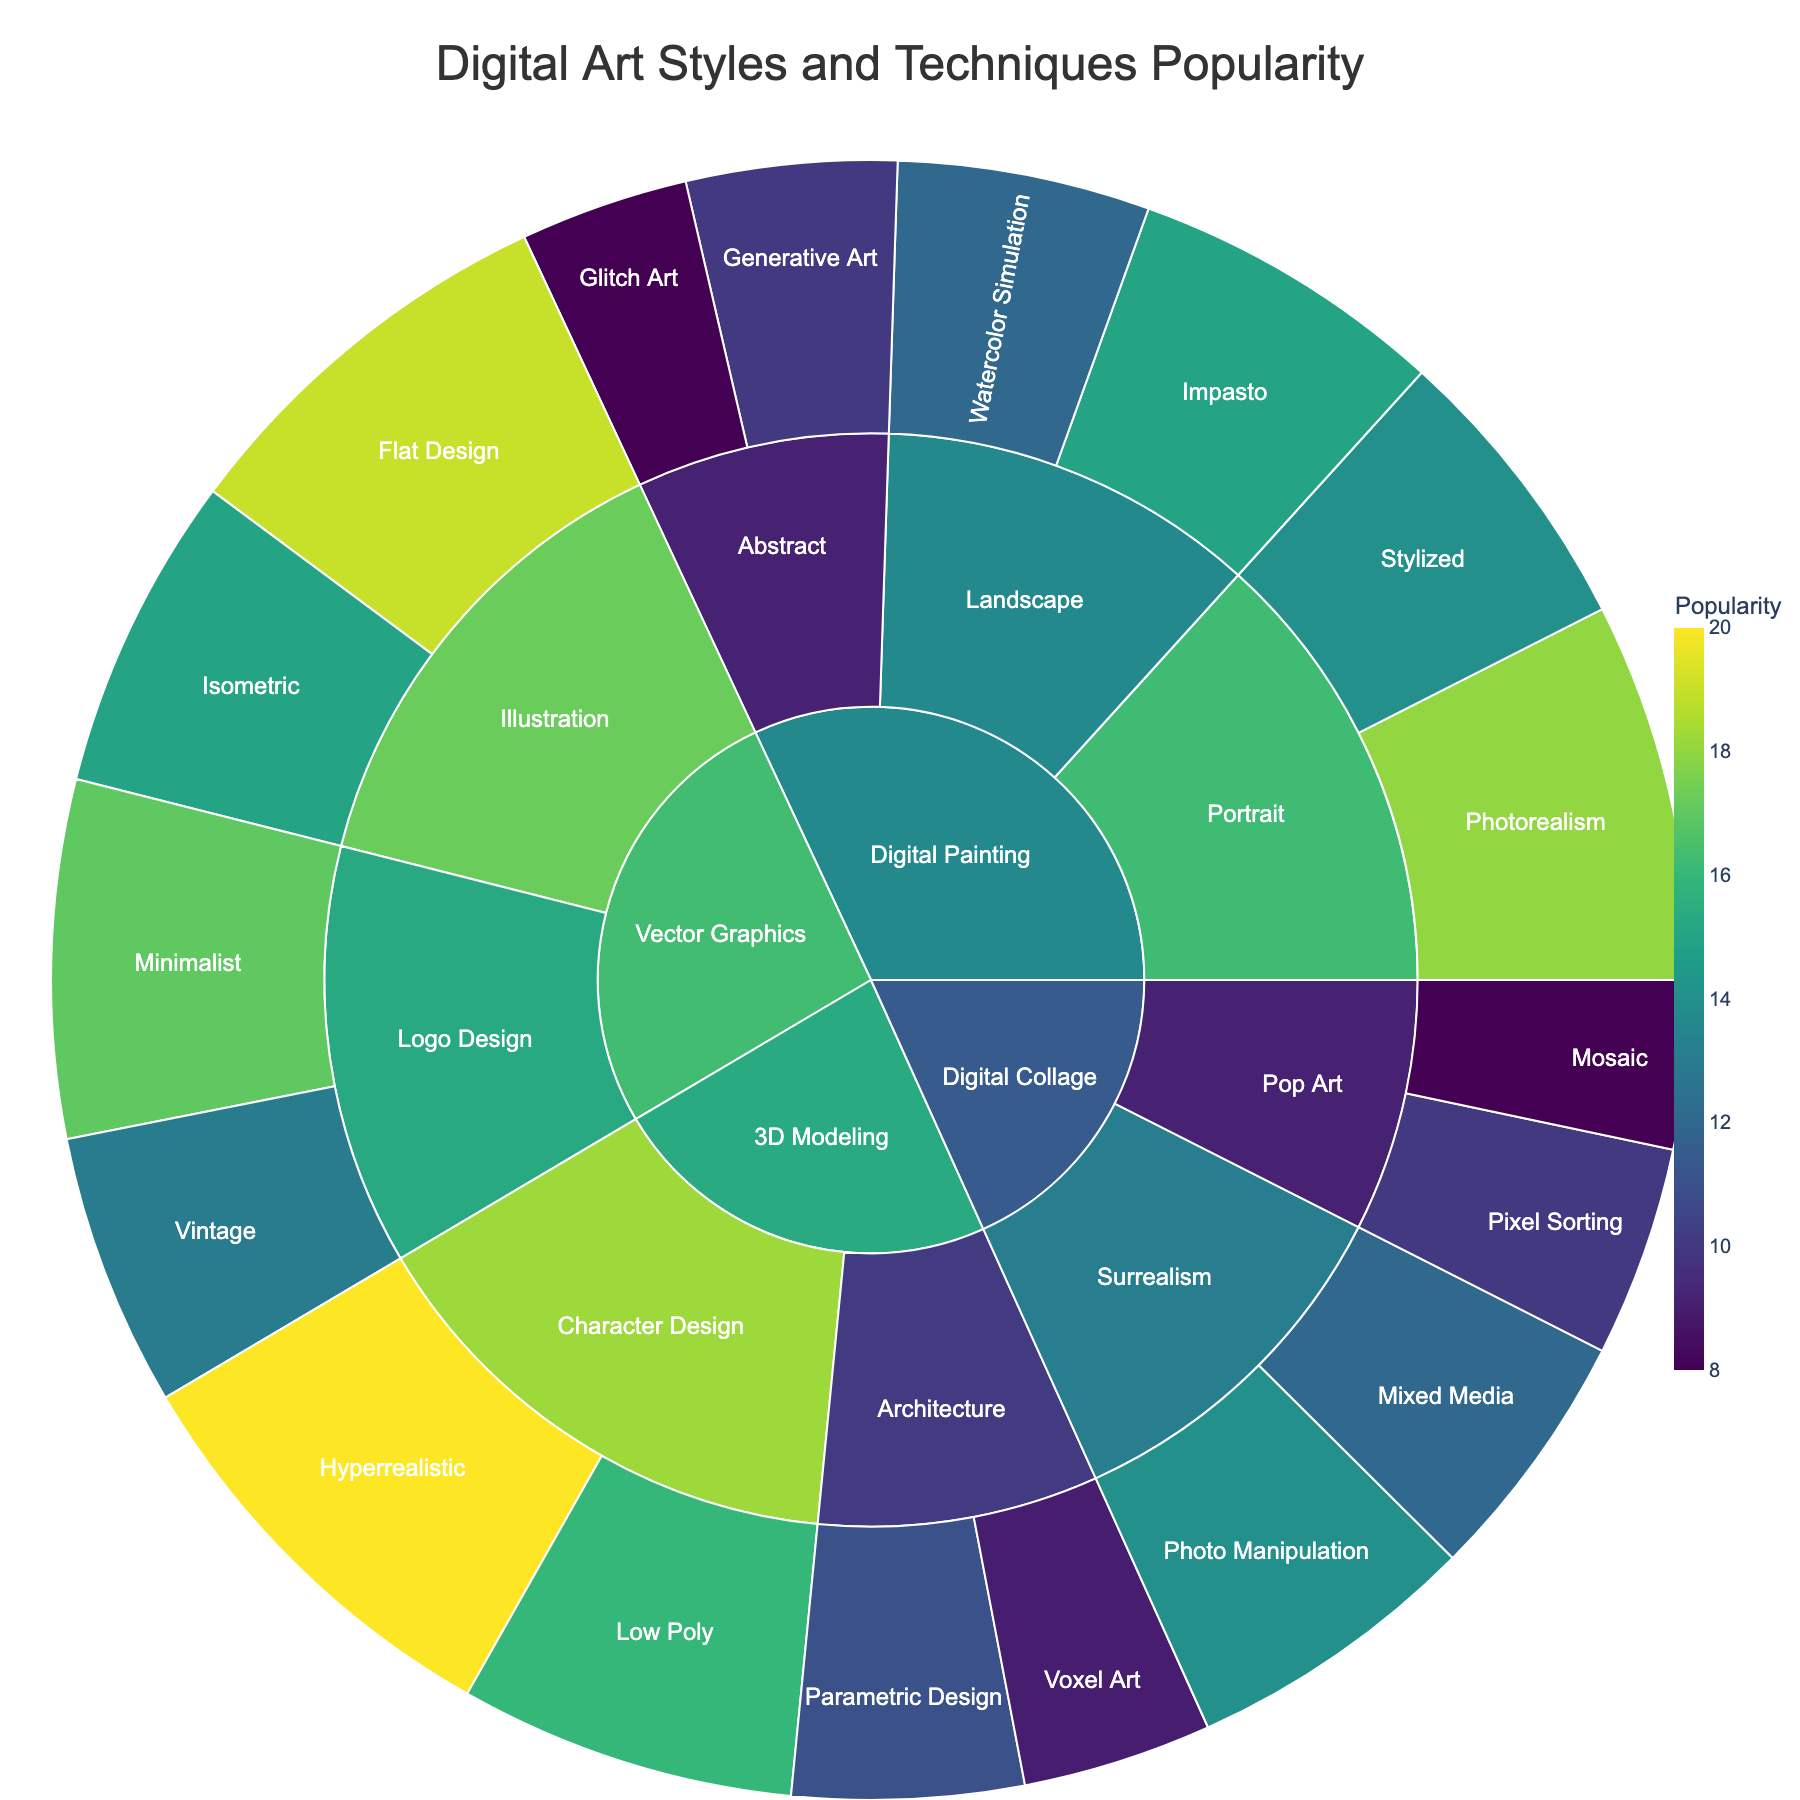What is the most popular digital art technique for the "Digital Painting" category? Look at the "Digital Painting" category and review the popularity values of its subcategories and techniques. The highest value is 18, which corresponds to "Photorealism" under the "Portrait" subcategory.
Answer: Photorealism Which subcategory within "3D Modeling" has a technique with popularity higher than 15? Examine the subcategories under "3D Modeling". Only "Character Design" has techniques with popularity higher than 15, evidenced by "Hyperrealistic" (20) and "Low Poly" (16).
Answer: Character Design Compare the popularity of "Minimalist" and "Vintage" techniques within "Vector Graphics". Which one is more popular? Look at the popularity values of "Minimalist" and "Vintage" within the "Logo Design" subcategory under "Vector Graphics". "Minimalist" has a popularity of 17, while "Vintage" has 13. Therefore, "Minimalist" is more popular.
Answer: Minimalist What is the least popular technique overall in the dataset? Check all the techniques and their respective popularity values. The lowest value is 8, which corresponds to "Glitch Art" and "Mosaic".
Answer: Glitch Art and Mosaic Which digital art category has the highest sum of popularity across all its techniques? Sum up the popularity values of each category: 
- Digital Painting: 15+12+18+14+10+8 = 77
- 3D Modeling: 16+20+11+9 = 56
- Vector Graphics: 17+13+19+15 = 64
- Digital Collage: 12+14+10+8 = 44
"Digital Painting" has the highest sum of 77.
Answer: Digital Painting How much more popular is the "Hyperrealistic" technique compared to the "Voxel Art" technique? The popularity of "Hyperrealistic" is 20, and the popularity of "Voxel Art" is 9. The difference is 20 - 9 = 11.
Answer: 11 What are the techniques listed under the "Surrealism" subcategory in "Digital Collage"? Review the techniques listed within the "Surrealism" subcategory under "Digital Collage". The techniques are "Mixed Media" and "Photo Manipulation".
Answer: Mixed Media and Photo Manipulation Identify the subcategory and technique with a popularity of 19. Look for the value 19 in the dataset. The technique "Flat Design" in the "Illustration" subcategory within "Vector Graphics" has this popularity.
Answer: Illustration, Flat Design Which technique has the second lowest popularity under the "Digital Painting" category? Within "Digital Painting", after sorting the techniques by popularity: 15, 12, 18, 14, 10, 8; the second lowest value is 10, which corresponds to "Generative Art" under the "Abstract" subcategory.
Answer: Generative Art What is the average popularity of techniques within the "Logo Design" subcategory of "Vector Graphics"? The popularity values within "Logo Design" under "Vector Graphics" are 17 and 13. The average is (17 + 13) / 2 = 15.
Answer: 15 